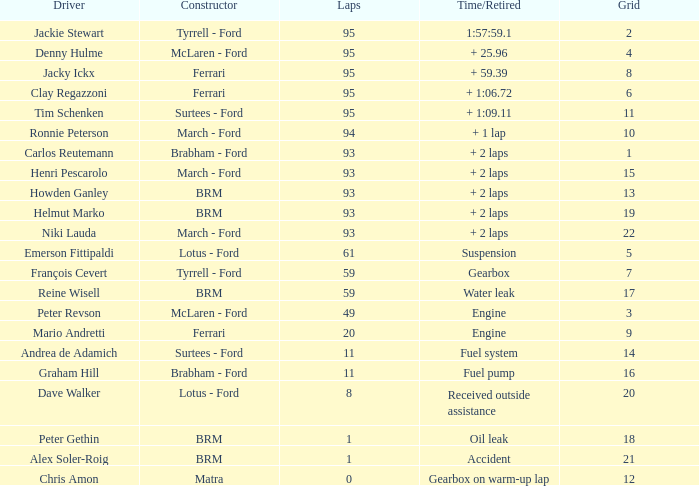What is the lowest grid with matra as constructor? 12.0. 